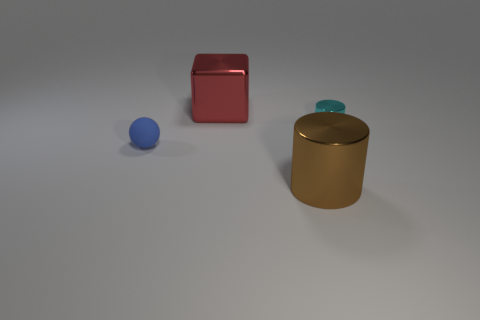How many red cubes are the same size as the brown shiny thing?
Your response must be concise. 1. What number of large shiny cubes are behind the tiny object that is to the left of the small cyan metal thing?
Keep it short and to the point. 1. There is a metal object that is in front of the big red metal thing and behind the big metallic cylinder; what is its size?
Your answer should be very brief. Small. Is the number of metallic objects greater than the number of tiny cylinders?
Your answer should be very brief. Yes. Are there any metal cubes that have the same color as the tiny matte object?
Make the answer very short. No. There is a thing that is to the left of the metallic block; does it have the same size as the red cube?
Offer a terse response. No. Are there fewer tiny green matte cylinders than tiny cylinders?
Your answer should be very brief. Yes. Are there any blue things that have the same material as the big brown cylinder?
Your response must be concise. No. There is a big thing in front of the tiny blue object; what shape is it?
Ensure brevity in your answer.  Cylinder. Is the color of the big metallic object that is behind the cyan metal cylinder the same as the matte ball?
Ensure brevity in your answer.  No. 